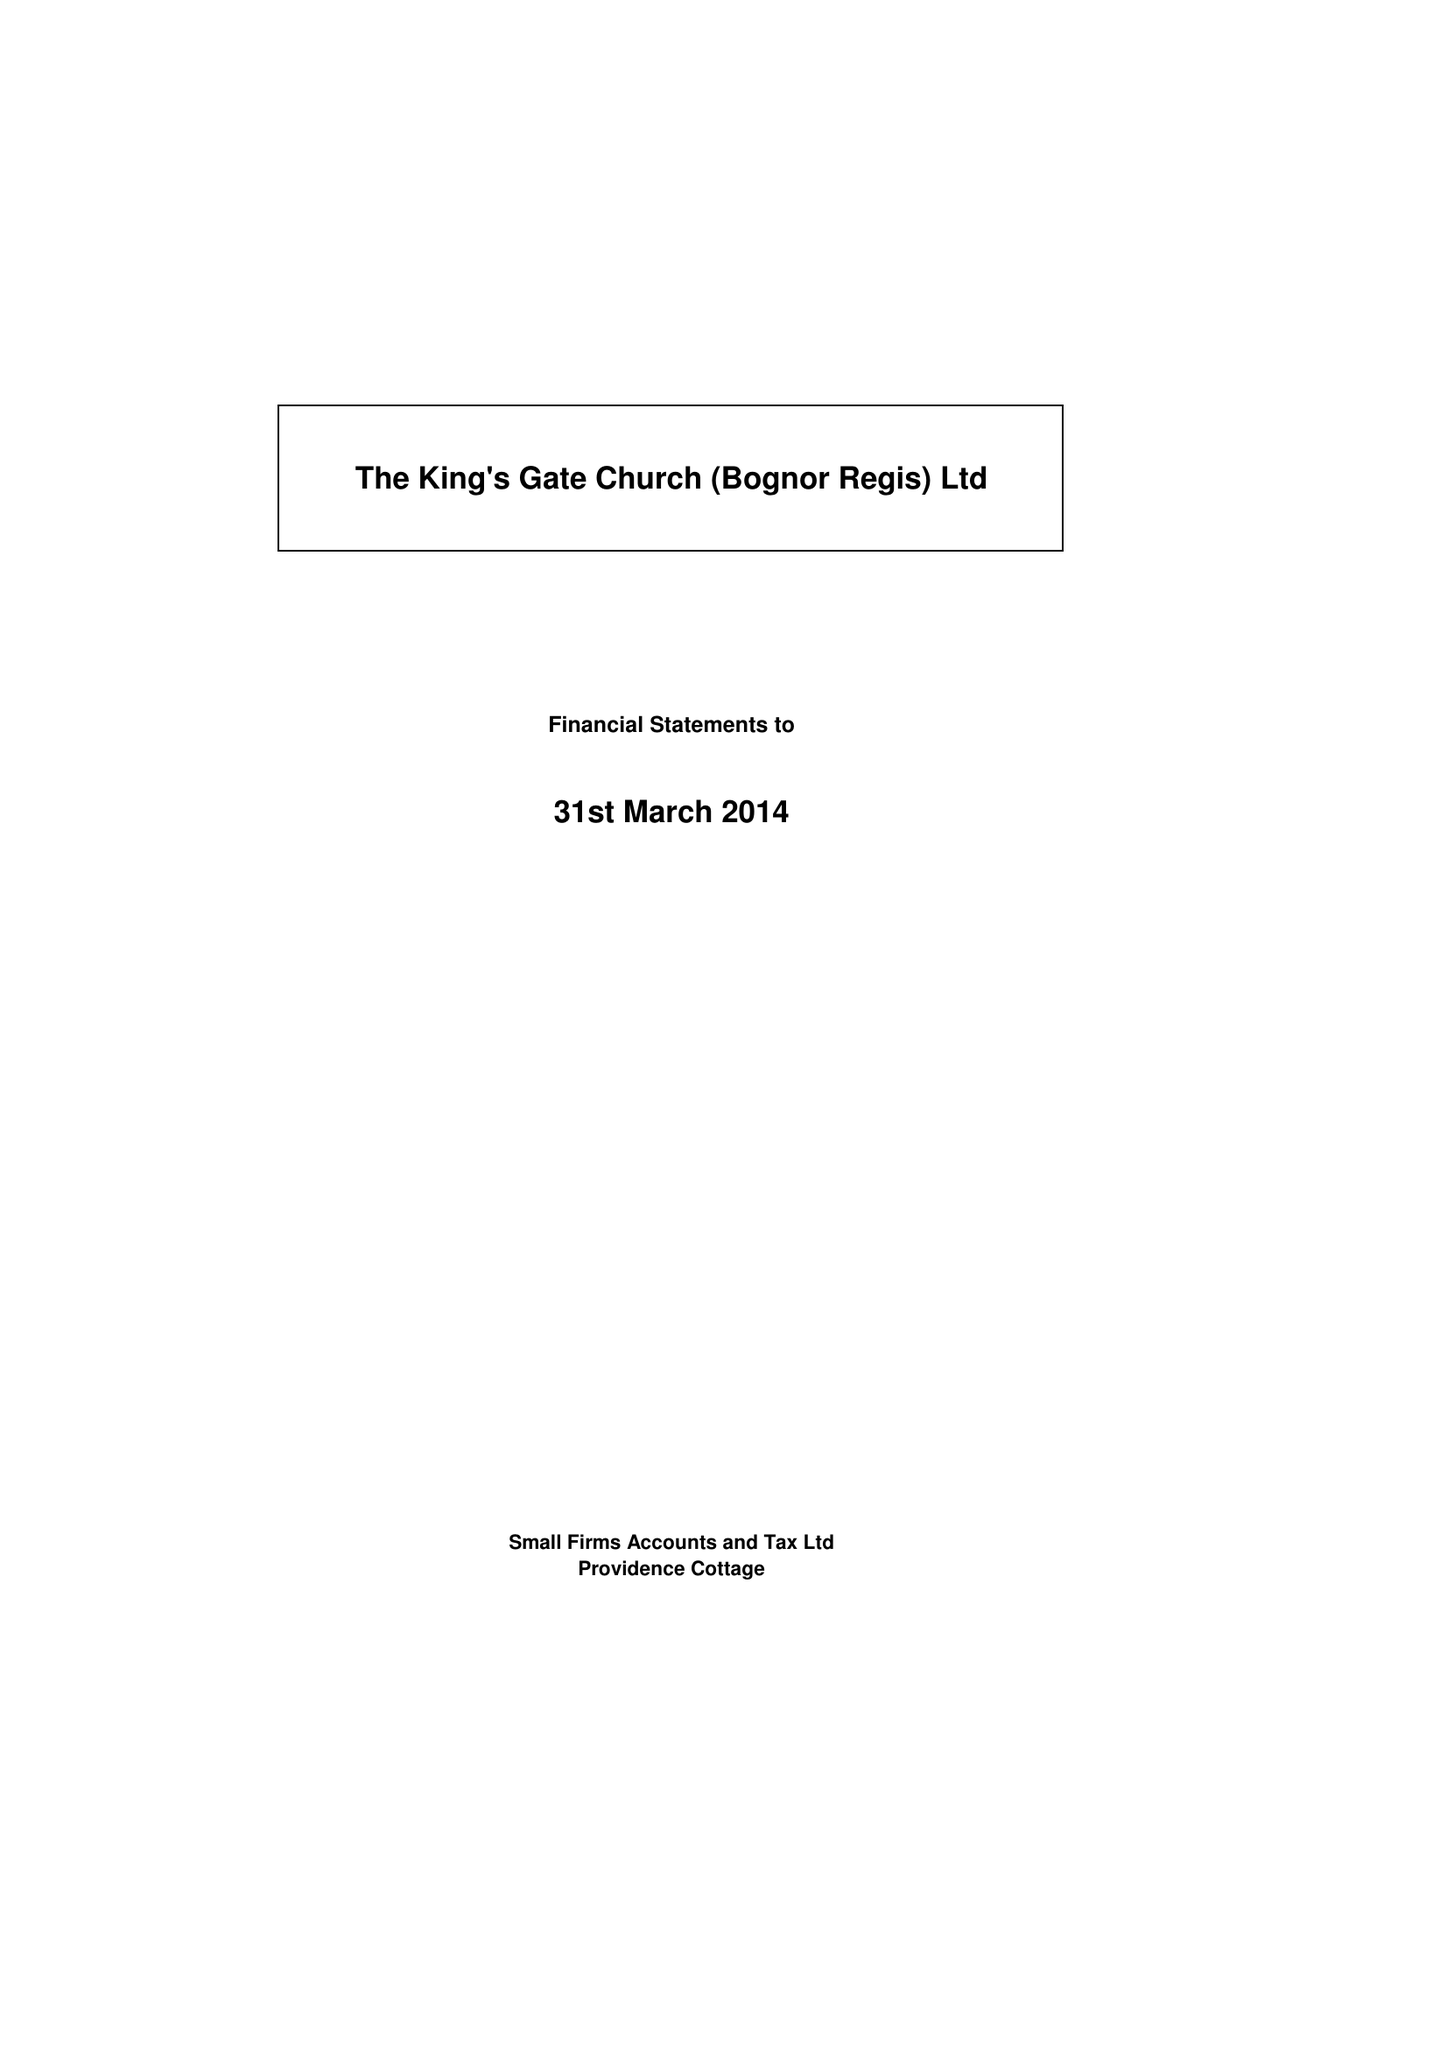What is the value for the address__postcode?
Answer the question using a single word or phrase. PO21 1QG 